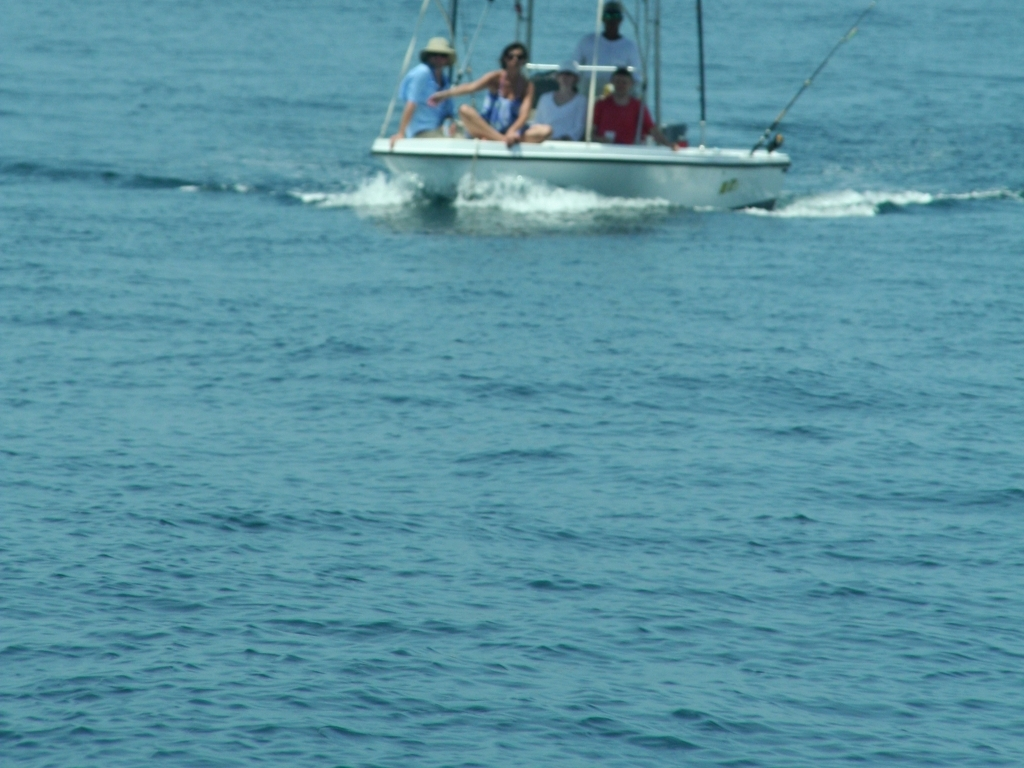What kind of activity are the people in the boat engaged in? The people in the boat appear to be engaged in recreational fishing. You can tell by the fishing rods extended over the water and their casual, seated postures indicative of a relaxed outing on the waves. 